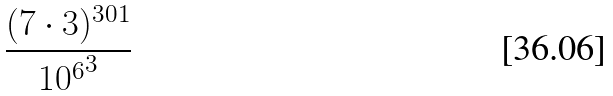Convert formula to latex. <formula><loc_0><loc_0><loc_500><loc_500>\frac { ( 7 \cdot 3 ) ^ { 3 0 1 } } { { 1 0 ^ { 6 } } ^ { 3 } }</formula> 